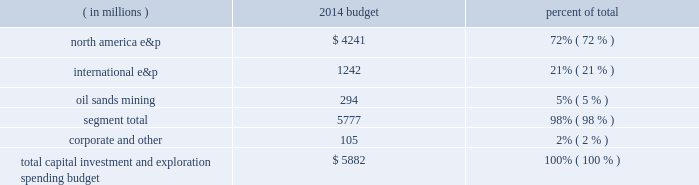Outlook budget our board of directors approved a capital , investment and exploration spending budget of $ 5882 million for 2014 , including budgeted capital expenditures of $ 5777 million .
Our capital , investment and exploration spending budget is broken down by reportable segment in the table below .
( in millions ) 2014 budget percent of .
We continue to focus on growing profitable reserves and production worldwide .
In 2014 , we are accelerating drilling activity in our three key u.s .
Unconventional resource plays : the eagle ford , bakken and oklahoma resource basins , which account for approximately 60 percent of our budget .
The majority of spending in our unconventional resource plays is intended for drilling .
With an increased number of rigs in each of these areas , we plan to drill more net wells in these areas than in any previous year .
We also have dedicated a portion of our capital budget in these areas to facility construction and recompletions .
In our conventional assets , we will follow a disciplined spending plan that is intended to provide stable productionwith approximately 23 percent of our budget allocated to the development of these assets worldwide .
We also plan to either drill or participate in 8 to 10 exploration wells throughout our portfolio , with 10 percent of our budget allocated to exploration projects .
For additional information about expected exploration and development activities see item 1 .
Business .
The above discussion includes forward-looking statements with respect to projected spending and investment in exploration and development activities under the 2014 capital , investment and exploration spending budget , accelerated rig and drilling activity in the eagle ford , bakken , and oklahoma resource basins , and future exploratory and development drilling activity .
Some factors which could potentially affect these forward-looking statements include pricing , supply and demand for liquid hydrocarbons and natural gas , the amount of capital available for exploration and development , regulatory constraints , timing of commencing production from new wells , drilling rig availability , availability of materials and labor , other risks associated with construction projects , unforeseen hazards such as weather conditions , acts of war or terrorist acts and the governmental or military response , and other geological , operating and economic considerations .
These forward-looking statements may be further affected by the inability to obtain or delay in obtaining necessary government and third-party approvals or permits .
The development projects could further be affected by presently known data concerning size and character of reservoirs , economic recoverability , future drilling success and production experience .
The foregoing factors ( among others ) could cause actual results to differ materially from those set forth in the forward-looking statements .
Sales volumes we expect to increase our u.s .
Resource plays' net sales volumes by more than 30 percent in 2014 compared to 2013 , excluding dispositions .
In addition , we expect total production growth to be approximately 4 percent in 2014 versus 2013 , excluding dispositions and libya .
Acquisitions and dispositions excluded from our budget are the impacts of acquisitions and dispositions not previously announced .
We continually evaluate ways to optimize our portfolio through acquisitions and divestitures and exceeded our previously stated goal of divesting between $ 1.5 billion and $ 3.0 billion of assets over the period of 2011 through 2013 .
For the three-year period ended december 31 , 2013 , we closed or entered agreements for approximately $ 3.5 billion in divestitures , of which $ 2.1 billion is from the sales of our angola assets .
The sale of our interest in angola block 31 closed in february 2014 and the sale of our interest in angola block 32 is expected to close in the first quarter of 2014 .
In december 2013 , we announced the commencement of efforts to market our assets in the north sea , both in the u.k .
And norway , which would simplify and concentrate our portfolio to higher margin growth opportunities and increase our production growth rate .
The above discussion includes forward-looking statements with respect to our percentage growth rate of production , production available for sale , the sale of our interest in angola block 32 and the possible sale of our u.k .
And norway assets .
Some factors .
Corporate and other expenses were what percent of the total capital investment and exploration spending budget? 
Computations: (105 / 5882)
Answer: 0.01785. 